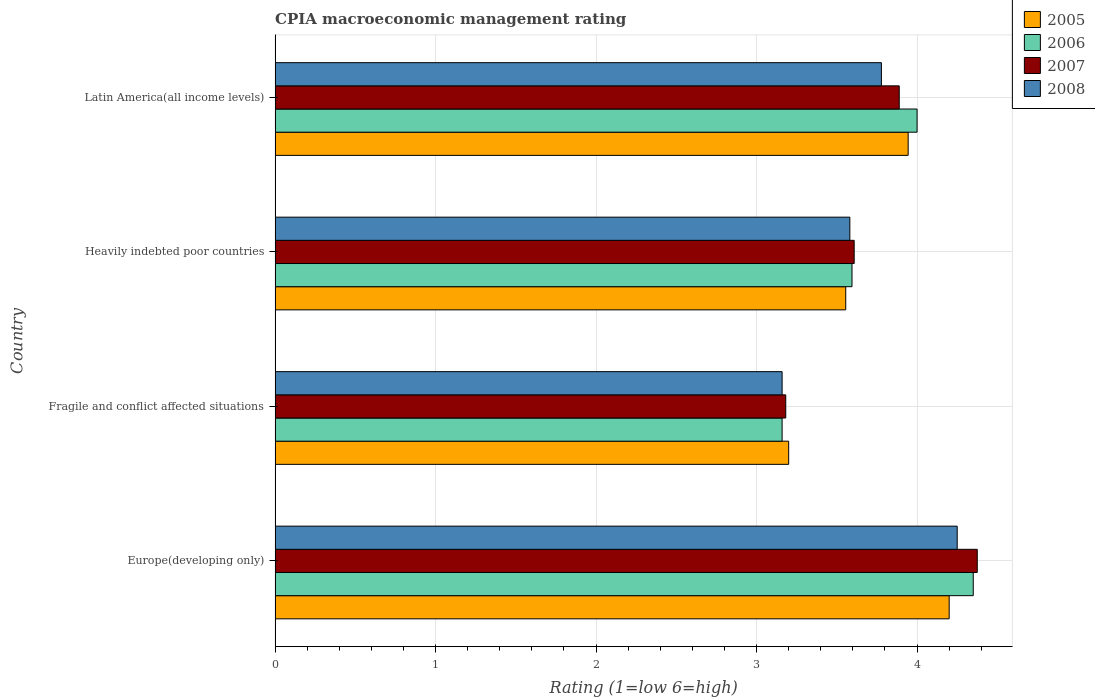How many different coloured bars are there?
Offer a terse response. 4. How many groups of bars are there?
Your answer should be compact. 4. Are the number of bars on each tick of the Y-axis equal?
Your answer should be very brief. Yes. How many bars are there on the 4th tick from the bottom?
Offer a very short reply. 4. What is the label of the 4th group of bars from the top?
Your answer should be very brief. Europe(developing only). In how many cases, is the number of bars for a given country not equal to the number of legend labels?
Offer a terse response. 0. What is the CPIA rating in 2006 in Heavily indebted poor countries?
Give a very brief answer. 3.59. Across all countries, what is the maximum CPIA rating in 2006?
Provide a succinct answer. 4.35. Across all countries, what is the minimum CPIA rating in 2008?
Provide a short and direct response. 3.16. In which country was the CPIA rating in 2007 maximum?
Provide a succinct answer. Europe(developing only). In which country was the CPIA rating in 2005 minimum?
Ensure brevity in your answer.  Fragile and conflict affected situations. What is the total CPIA rating in 2008 in the graph?
Offer a very short reply. 14.77. What is the difference between the CPIA rating in 2007 in Heavily indebted poor countries and that in Latin America(all income levels)?
Provide a short and direct response. -0.28. What is the difference between the CPIA rating in 2005 in Latin America(all income levels) and the CPIA rating in 2008 in Europe(developing only)?
Ensure brevity in your answer.  -0.31. What is the average CPIA rating in 2005 per country?
Give a very brief answer. 3.72. What is the difference between the CPIA rating in 2006 and CPIA rating in 2008 in Latin America(all income levels)?
Provide a short and direct response. 0.22. In how many countries, is the CPIA rating in 2007 greater than 0.8 ?
Make the answer very short. 4. What is the ratio of the CPIA rating in 2005 in Europe(developing only) to that in Latin America(all income levels)?
Your answer should be very brief. 1.06. What is the difference between the highest and the second highest CPIA rating in 2008?
Ensure brevity in your answer.  0.47. What is the difference between the highest and the lowest CPIA rating in 2005?
Provide a succinct answer. 1. Is the sum of the CPIA rating in 2008 in Heavily indebted poor countries and Latin America(all income levels) greater than the maximum CPIA rating in 2005 across all countries?
Your answer should be very brief. Yes. Is it the case that in every country, the sum of the CPIA rating in 2007 and CPIA rating in 2005 is greater than the sum of CPIA rating in 2008 and CPIA rating in 2006?
Your answer should be very brief. No. Is it the case that in every country, the sum of the CPIA rating in 2008 and CPIA rating in 2005 is greater than the CPIA rating in 2006?
Make the answer very short. Yes. How many bars are there?
Make the answer very short. 16. Are all the bars in the graph horizontal?
Your response must be concise. Yes. What is the difference between two consecutive major ticks on the X-axis?
Offer a very short reply. 1. Are the values on the major ticks of X-axis written in scientific E-notation?
Offer a terse response. No. Does the graph contain any zero values?
Provide a short and direct response. No. What is the title of the graph?
Your response must be concise. CPIA macroeconomic management rating. What is the Rating (1=low 6=high) in 2006 in Europe(developing only)?
Ensure brevity in your answer.  4.35. What is the Rating (1=low 6=high) in 2007 in Europe(developing only)?
Your answer should be very brief. 4.38. What is the Rating (1=low 6=high) of 2008 in Europe(developing only)?
Offer a terse response. 4.25. What is the Rating (1=low 6=high) of 2006 in Fragile and conflict affected situations?
Your answer should be very brief. 3.16. What is the Rating (1=low 6=high) in 2007 in Fragile and conflict affected situations?
Give a very brief answer. 3.18. What is the Rating (1=low 6=high) of 2008 in Fragile and conflict affected situations?
Your answer should be very brief. 3.16. What is the Rating (1=low 6=high) in 2005 in Heavily indebted poor countries?
Provide a succinct answer. 3.56. What is the Rating (1=low 6=high) in 2006 in Heavily indebted poor countries?
Keep it short and to the point. 3.59. What is the Rating (1=low 6=high) in 2007 in Heavily indebted poor countries?
Make the answer very short. 3.61. What is the Rating (1=low 6=high) in 2008 in Heavily indebted poor countries?
Your answer should be compact. 3.58. What is the Rating (1=low 6=high) in 2005 in Latin America(all income levels)?
Give a very brief answer. 3.94. What is the Rating (1=low 6=high) in 2007 in Latin America(all income levels)?
Your response must be concise. 3.89. What is the Rating (1=low 6=high) of 2008 in Latin America(all income levels)?
Ensure brevity in your answer.  3.78. Across all countries, what is the maximum Rating (1=low 6=high) of 2006?
Provide a short and direct response. 4.35. Across all countries, what is the maximum Rating (1=low 6=high) of 2007?
Offer a terse response. 4.38. Across all countries, what is the maximum Rating (1=low 6=high) in 2008?
Make the answer very short. 4.25. Across all countries, what is the minimum Rating (1=low 6=high) of 2005?
Offer a terse response. 3.2. Across all countries, what is the minimum Rating (1=low 6=high) of 2006?
Offer a terse response. 3.16. Across all countries, what is the minimum Rating (1=low 6=high) in 2007?
Your answer should be compact. 3.18. Across all countries, what is the minimum Rating (1=low 6=high) of 2008?
Give a very brief answer. 3.16. What is the total Rating (1=low 6=high) of 2006 in the graph?
Provide a succinct answer. 15.1. What is the total Rating (1=low 6=high) of 2007 in the graph?
Provide a succinct answer. 15.05. What is the total Rating (1=low 6=high) in 2008 in the graph?
Provide a succinct answer. 14.77. What is the difference between the Rating (1=low 6=high) of 2005 in Europe(developing only) and that in Fragile and conflict affected situations?
Your answer should be compact. 1. What is the difference between the Rating (1=low 6=high) in 2006 in Europe(developing only) and that in Fragile and conflict affected situations?
Give a very brief answer. 1.19. What is the difference between the Rating (1=low 6=high) in 2007 in Europe(developing only) and that in Fragile and conflict affected situations?
Your response must be concise. 1.19. What is the difference between the Rating (1=low 6=high) in 2008 in Europe(developing only) and that in Fragile and conflict affected situations?
Give a very brief answer. 1.09. What is the difference between the Rating (1=low 6=high) of 2005 in Europe(developing only) and that in Heavily indebted poor countries?
Your answer should be compact. 0.64. What is the difference between the Rating (1=low 6=high) in 2006 in Europe(developing only) and that in Heavily indebted poor countries?
Provide a succinct answer. 0.76. What is the difference between the Rating (1=low 6=high) of 2007 in Europe(developing only) and that in Heavily indebted poor countries?
Keep it short and to the point. 0.77. What is the difference between the Rating (1=low 6=high) of 2008 in Europe(developing only) and that in Heavily indebted poor countries?
Offer a very short reply. 0.67. What is the difference between the Rating (1=low 6=high) of 2005 in Europe(developing only) and that in Latin America(all income levels)?
Ensure brevity in your answer.  0.26. What is the difference between the Rating (1=low 6=high) of 2007 in Europe(developing only) and that in Latin America(all income levels)?
Give a very brief answer. 0.49. What is the difference between the Rating (1=low 6=high) in 2008 in Europe(developing only) and that in Latin America(all income levels)?
Provide a short and direct response. 0.47. What is the difference between the Rating (1=low 6=high) in 2005 in Fragile and conflict affected situations and that in Heavily indebted poor countries?
Your answer should be compact. -0.36. What is the difference between the Rating (1=low 6=high) in 2006 in Fragile and conflict affected situations and that in Heavily indebted poor countries?
Ensure brevity in your answer.  -0.44. What is the difference between the Rating (1=low 6=high) in 2007 in Fragile and conflict affected situations and that in Heavily indebted poor countries?
Provide a short and direct response. -0.43. What is the difference between the Rating (1=low 6=high) in 2008 in Fragile and conflict affected situations and that in Heavily indebted poor countries?
Offer a terse response. -0.42. What is the difference between the Rating (1=low 6=high) of 2005 in Fragile and conflict affected situations and that in Latin America(all income levels)?
Provide a short and direct response. -0.74. What is the difference between the Rating (1=low 6=high) in 2006 in Fragile and conflict affected situations and that in Latin America(all income levels)?
Your answer should be compact. -0.84. What is the difference between the Rating (1=low 6=high) in 2007 in Fragile and conflict affected situations and that in Latin America(all income levels)?
Provide a short and direct response. -0.71. What is the difference between the Rating (1=low 6=high) in 2008 in Fragile and conflict affected situations and that in Latin America(all income levels)?
Your response must be concise. -0.62. What is the difference between the Rating (1=low 6=high) in 2005 in Heavily indebted poor countries and that in Latin America(all income levels)?
Offer a very short reply. -0.39. What is the difference between the Rating (1=low 6=high) of 2006 in Heavily indebted poor countries and that in Latin America(all income levels)?
Your answer should be very brief. -0.41. What is the difference between the Rating (1=low 6=high) in 2007 in Heavily indebted poor countries and that in Latin America(all income levels)?
Keep it short and to the point. -0.28. What is the difference between the Rating (1=low 6=high) in 2008 in Heavily indebted poor countries and that in Latin America(all income levels)?
Give a very brief answer. -0.2. What is the difference between the Rating (1=low 6=high) in 2005 in Europe(developing only) and the Rating (1=low 6=high) in 2006 in Fragile and conflict affected situations?
Provide a short and direct response. 1.04. What is the difference between the Rating (1=low 6=high) of 2005 in Europe(developing only) and the Rating (1=low 6=high) of 2007 in Fragile and conflict affected situations?
Ensure brevity in your answer.  1.02. What is the difference between the Rating (1=low 6=high) of 2005 in Europe(developing only) and the Rating (1=low 6=high) of 2008 in Fragile and conflict affected situations?
Offer a very short reply. 1.04. What is the difference between the Rating (1=low 6=high) in 2006 in Europe(developing only) and the Rating (1=low 6=high) in 2007 in Fragile and conflict affected situations?
Ensure brevity in your answer.  1.17. What is the difference between the Rating (1=low 6=high) of 2006 in Europe(developing only) and the Rating (1=low 6=high) of 2008 in Fragile and conflict affected situations?
Offer a terse response. 1.19. What is the difference between the Rating (1=low 6=high) of 2007 in Europe(developing only) and the Rating (1=low 6=high) of 2008 in Fragile and conflict affected situations?
Your answer should be compact. 1.22. What is the difference between the Rating (1=low 6=high) of 2005 in Europe(developing only) and the Rating (1=low 6=high) of 2006 in Heavily indebted poor countries?
Your response must be concise. 0.61. What is the difference between the Rating (1=low 6=high) in 2005 in Europe(developing only) and the Rating (1=low 6=high) in 2007 in Heavily indebted poor countries?
Ensure brevity in your answer.  0.59. What is the difference between the Rating (1=low 6=high) of 2005 in Europe(developing only) and the Rating (1=low 6=high) of 2008 in Heavily indebted poor countries?
Offer a terse response. 0.62. What is the difference between the Rating (1=low 6=high) of 2006 in Europe(developing only) and the Rating (1=low 6=high) of 2007 in Heavily indebted poor countries?
Your response must be concise. 0.74. What is the difference between the Rating (1=low 6=high) in 2006 in Europe(developing only) and the Rating (1=low 6=high) in 2008 in Heavily indebted poor countries?
Provide a succinct answer. 0.77. What is the difference between the Rating (1=low 6=high) of 2007 in Europe(developing only) and the Rating (1=low 6=high) of 2008 in Heavily indebted poor countries?
Provide a succinct answer. 0.79. What is the difference between the Rating (1=low 6=high) of 2005 in Europe(developing only) and the Rating (1=low 6=high) of 2006 in Latin America(all income levels)?
Ensure brevity in your answer.  0.2. What is the difference between the Rating (1=low 6=high) in 2005 in Europe(developing only) and the Rating (1=low 6=high) in 2007 in Latin America(all income levels)?
Offer a terse response. 0.31. What is the difference between the Rating (1=low 6=high) of 2005 in Europe(developing only) and the Rating (1=low 6=high) of 2008 in Latin America(all income levels)?
Ensure brevity in your answer.  0.42. What is the difference between the Rating (1=low 6=high) in 2006 in Europe(developing only) and the Rating (1=low 6=high) in 2007 in Latin America(all income levels)?
Offer a very short reply. 0.46. What is the difference between the Rating (1=low 6=high) of 2006 in Europe(developing only) and the Rating (1=low 6=high) of 2008 in Latin America(all income levels)?
Give a very brief answer. 0.57. What is the difference between the Rating (1=low 6=high) in 2007 in Europe(developing only) and the Rating (1=low 6=high) in 2008 in Latin America(all income levels)?
Give a very brief answer. 0.6. What is the difference between the Rating (1=low 6=high) of 2005 in Fragile and conflict affected situations and the Rating (1=low 6=high) of 2006 in Heavily indebted poor countries?
Keep it short and to the point. -0.39. What is the difference between the Rating (1=low 6=high) of 2005 in Fragile and conflict affected situations and the Rating (1=low 6=high) of 2007 in Heavily indebted poor countries?
Make the answer very short. -0.41. What is the difference between the Rating (1=low 6=high) in 2005 in Fragile and conflict affected situations and the Rating (1=low 6=high) in 2008 in Heavily indebted poor countries?
Offer a terse response. -0.38. What is the difference between the Rating (1=low 6=high) in 2006 in Fragile and conflict affected situations and the Rating (1=low 6=high) in 2007 in Heavily indebted poor countries?
Your response must be concise. -0.45. What is the difference between the Rating (1=low 6=high) of 2006 in Fragile and conflict affected situations and the Rating (1=low 6=high) of 2008 in Heavily indebted poor countries?
Provide a short and direct response. -0.42. What is the difference between the Rating (1=low 6=high) in 2007 in Fragile and conflict affected situations and the Rating (1=low 6=high) in 2008 in Heavily indebted poor countries?
Give a very brief answer. -0.4. What is the difference between the Rating (1=low 6=high) in 2005 in Fragile and conflict affected situations and the Rating (1=low 6=high) in 2006 in Latin America(all income levels)?
Offer a very short reply. -0.8. What is the difference between the Rating (1=low 6=high) of 2005 in Fragile and conflict affected situations and the Rating (1=low 6=high) of 2007 in Latin America(all income levels)?
Offer a very short reply. -0.69. What is the difference between the Rating (1=low 6=high) in 2005 in Fragile and conflict affected situations and the Rating (1=low 6=high) in 2008 in Latin America(all income levels)?
Ensure brevity in your answer.  -0.58. What is the difference between the Rating (1=low 6=high) in 2006 in Fragile and conflict affected situations and the Rating (1=low 6=high) in 2007 in Latin America(all income levels)?
Ensure brevity in your answer.  -0.73. What is the difference between the Rating (1=low 6=high) in 2006 in Fragile and conflict affected situations and the Rating (1=low 6=high) in 2008 in Latin America(all income levels)?
Ensure brevity in your answer.  -0.62. What is the difference between the Rating (1=low 6=high) in 2007 in Fragile and conflict affected situations and the Rating (1=low 6=high) in 2008 in Latin America(all income levels)?
Offer a very short reply. -0.6. What is the difference between the Rating (1=low 6=high) in 2005 in Heavily indebted poor countries and the Rating (1=low 6=high) in 2006 in Latin America(all income levels)?
Your answer should be very brief. -0.44. What is the difference between the Rating (1=low 6=high) in 2005 in Heavily indebted poor countries and the Rating (1=low 6=high) in 2008 in Latin America(all income levels)?
Your answer should be very brief. -0.22. What is the difference between the Rating (1=low 6=high) of 2006 in Heavily indebted poor countries and the Rating (1=low 6=high) of 2007 in Latin America(all income levels)?
Your answer should be very brief. -0.29. What is the difference between the Rating (1=low 6=high) of 2006 in Heavily indebted poor countries and the Rating (1=low 6=high) of 2008 in Latin America(all income levels)?
Keep it short and to the point. -0.18. What is the difference between the Rating (1=low 6=high) of 2007 in Heavily indebted poor countries and the Rating (1=low 6=high) of 2008 in Latin America(all income levels)?
Provide a short and direct response. -0.17. What is the average Rating (1=low 6=high) in 2005 per country?
Your response must be concise. 3.73. What is the average Rating (1=low 6=high) in 2006 per country?
Your answer should be compact. 3.78. What is the average Rating (1=low 6=high) of 2007 per country?
Offer a terse response. 3.76. What is the average Rating (1=low 6=high) in 2008 per country?
Make the answer very short. 3.69. What is the difference between the Rating (1=low 6=high) in 2005 and Rating (1=low 6=high) in 2006 in Europe(developing only)?
Your answer should be very brief. -0.15. What is the difference between the Rating (1=low 6=high) in 2005 and Rating (1=low 6=high) in 2007 in Europe(developing only)?
Offer a very short reply. -0.17. What is the difference between the Rating (1=low 6=high) of 2006 and Rating (1=low 6=high) of 2007 in Europe(developing only)?
Your answer should be very brief. -0.03. What is the difference between the Rating (1=low 6=high) in 2006 and Rating (1=low 6=high) in 2008 in Europe(developing only)?
Your response must be concise. 0.1. What is the difference between the Rating (1=low 6=high) in 2007 and Rating (1=low 6=high) in 2008 in Europe(developing only)?
Offer a very short reply. 0.12. What is the difference between the Rating (1=low 6=high) in 2005 and Rating (1=low 6=high) in 2006 in Fragile and conflict affected situations?
Offer a terse response. 0.04. What is the difference between the Rating (1=low 6=high) in 2005 and Rating (1=low 6=high) in 2007 in Fragile and conflict affected situations?
Provide a short and direct response. 0.02. What is the difference between the Rating (1=low 6=high) in 2005 and Rating (1=low 6=high) in 2008 in Fragile and conflict affected situations?
Offer a terse response. 0.04. What is the difference between the Rating (1=low 6=high) of 2006 and Rating (1=low 6=high) of 2007 in Fragile and conflict affected situations?
Provide a short and direct response. -0.02. What is the difference between the Rating (1=low 6=high) in 2006 and Rating (1=low 6=high) in 2008 in Fragile and conflict affected situations?
Your answer should be very brief. 0. What is the difference between the Rating (1=low 6=high) in 2007 and Rating (1=low 6=high) in 2008 in Fragile and conflict affected situations?
Give a very brief answer. 0.02. What is the difference between the Rating (1=low 6=high) of 2005 and Rating (1=low 6=high) of 2006 in Heavily indebted poor countries?
Your response must be concise. -0.04. What is the difference between the Rating (1=low 6=high) in 2005 and Rating (1=low 6=high) in 2007 in Heavily indebted poor countries?
Provide a succinct answer. -0.05. What is the difference between the Rating (1=low 6=high) of 2005 and Rating (1=low 6=high) of 2008 in Heavily indebted poor countries?
Give a very brief answer. -0.03. What is the difference between the Rating (1=low 6=high) of 2006 and Rating (1=low 6=high) of 2007 in Heavily indebted poor countries?
Your answer should be compact. -0.01. What is the difference between the Rating (1=low 6=high) of 2006 and Rating (1=low 6=high) of 2008 in Heavily indebted poor countries?
Make the answer very short. 0.01. What is the difference between the Rating (1=low 6=high) of 2007 and Rating (1=low 6=high) of 2008 in Heavily indebted poor countries?
Your response must be concise. 0.03. What is the difference between the Rating (1=low 6=high) in 2005 and Rating (1=low 6=high) in 2006 in Latin America(all income levels)?
Your response must be concise. -0.06. What is the difference between the Rating (1=low 6=high) of 2005 and Rating (1=low 6=high) of 2007 in Latin America(all income levels)?
Provide a succinct answer. 0.06. What is the difference between the Rating (1=low 6=high) in 2005 and Rating (1=low 6=high) in 2008 in Latin America(all income levels)?
Provide a succinct answer. 0.17. What is the difference between the Rating (1=low 6=high) in 2006 and Rating (1=low 6=high) in 2008 in Latin America(all income levels)?
Provide a short and direct response. 0.22. What is the difference between the Rating (1=low 6=high) in 2007 and Rating (1=low 6=high) in 2008 in Latin America(all income levels)?
Provide a succinct answer. 0.11. What is the ratio of the Rating (1=low 6=high) of 2005 in Europe(developing only) to that in Fragile and conflict affected situations?
Offer a very short reply. 1.31. What is the ratio of the Rating (1=low 6=high) of 2006 in Europe(developing only) to that in Fragile and conflict affected situations?
Your answer should be very brief. 1.38. What is the ratio of the Rating (1=low 6=high) in 2007 in Europe(developing only) to that in Fragile and conflict affected situations?
Keep it short and to the point. 1.38. What is the ratio of the Rating (1=low 6=high) in 2008 in Europe(developing only) to that in Fragile and conflict affected situations?
Provide a short and direct response. 1.35. What is the ratio of the Rating (1=low 6=high) in 2005 in Europe(developing only) to that in Heavily indebted poor countries?
Make the answer very short. 1.18. What is the ratio of the Rating (1=low 6=high) in 2006 in Europe(developing only) to that in Heavily indebted poor countries?
Your answer should be compact. 1.21. What is the ratio of the Rating (1=low 6=high) of 2007 in Europe(developing only) to that in Heavily indebted poor countries?
Your answer should be very brief. 1.21. What is the ratio of the Rating (1=low 6=high) in 2008 in Europe(developing only) to that in Heavily indebted poor countries?
Your answer should be very brief. 1.19. What is the ratio of the Rating (1=low 6=high) in 2005 in Europe(developing only) to that in Latin America(all income levels)?
Offer a terse response. 1.06. What is the ratio of the Rating (1=low 6=high) in 2006 in Europe(developing only) to that in Latin America(all income levels)?
Make the answer very short. 1.09. What is the ratio of the Rating (1=low 6=high) in 2005 in Fragile and conflict affected situations to that in Heavily indebted poor countries?
Keep it short and to the point. 0.9. What is the ratio of the Rating (1=low 6=high) of 2006 in Fragile and conflict affected situations to that in Heavily indebted poor countries?
Your answer should be very brief. 0.88. What is the ratio of the Rating (1=low 6=high) of 2007 in Fragile and conflict affected situations to that in Heavily indebted poor countries?
Offer a very short reply. 0.88. What is the ratio of the Rating (1=low 6=high) in 2008 in Fragile and conflict affected situations to that in Heavily indebted poor countries?
Your answer should be very brief. 0.88. What is the ratio of the Rating (1=low 6=high) of 2005 in Fragile and conflict affected situations to that in Latin America(all income levels)?
Ensure brevity in your answer.  0.81. What is the ratio of the Rating (1=low 6=high) of 2006 in Fragile and conflict affected situations to that in Latin America(all income levels)?
Ensure brevity in your answer.  0.79. What is the ratio of the Rating (1=low 6=high) in 2007 in Fragile and conflict affected situations to that in Latin America(all income levels)?
Ensure brevity in your answer.  0.82. What is the ratio of the Rating (1=low 6=high) of 2008 in Fragile and conflict affected situations to that in Latin America(all income levels)?
Your answer should be very brief. 0.84. What is the ratio of the Rating (1=low 6=high) of 2005 in Heavily indebted poor countries to that in Latin America(all income levels)?
Give a very brief answer. 0.9. What is the ratio of the Rating (1=low 6=high) in 2006 in Heavily indebted poor countries to that in Latin America(all income levels)?
Keep it short and to the point. 0.9. What is the ratio of the Rating (1=low 6=high) in 2007 in Heavily indebted poor countries to that in Latin America(all income levels)?
Provide a short and direct response. 0.93. What is the ratio of the Rating (1=low 6=high) of 2008 in Heavily indebted poor countries to that in Latin America(all income levels)?
Keep it short and to the point. 0.95. What is the difference between the highest and the second highest Rating (1=low 6=high) in 2005?
Your answer should be very brief. 0.26. What is the difference between the highest and the second highest Rating (1=low 6=high) in 2007?
Provide a succinct answer. 0.49. What is the difference between the highest and the second highest Rating (1=low 6=high) of 2008?
Offer a very short reply. 0.47. What is the difference between the highest and the lowest Rating (1=low 6=high) in 2006?
Your answer should be compact. 1.19. What is the difference between the highest and the lowest Rating (1=low 6=high) of 2007?
Provide a succinct answer. 1.19. 